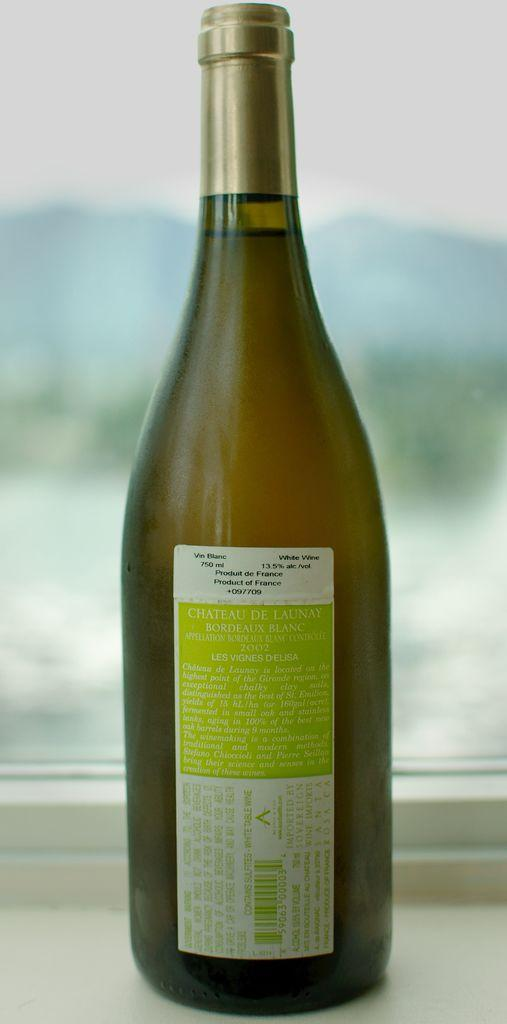<image>
Offer a succinct explanation of the picture presented. A bottle of wine called Chateau De Launay 